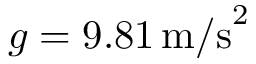Convert formula to latex. <formula><loc_0><loc_0><loc_500><loc_500>g = 9 . 8 1 \, m / s ^ { 2 }</formula> 